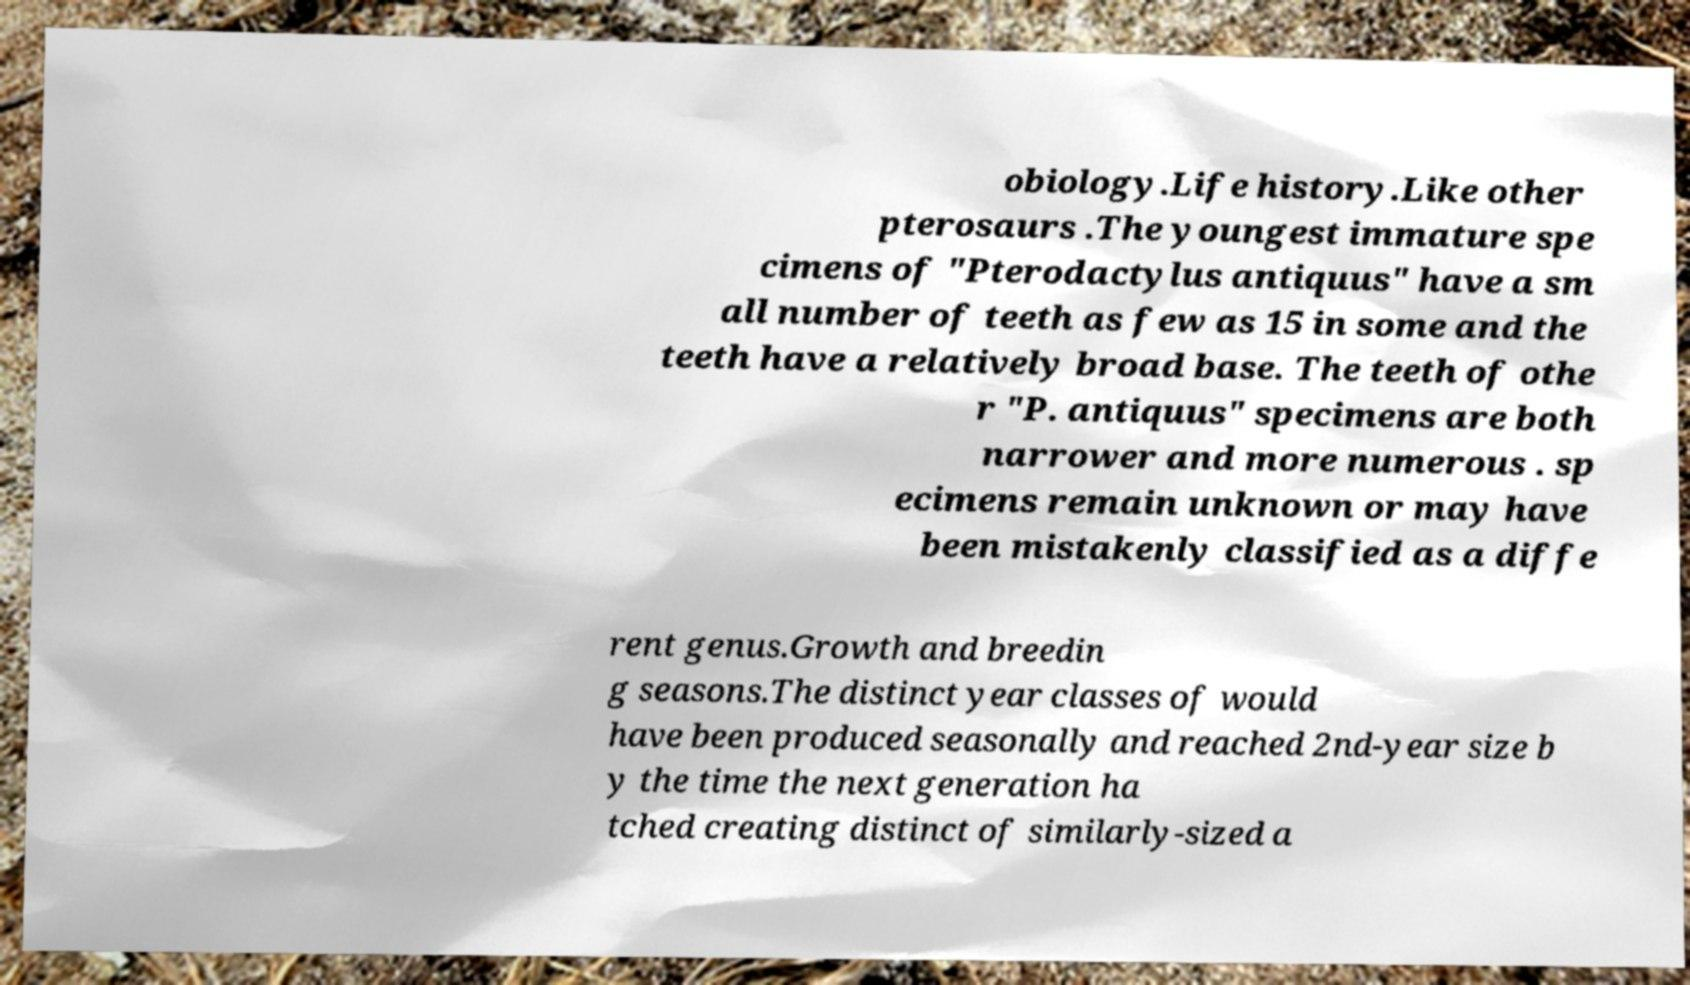Please identify and transcribe the text found in this image. obiology.Life history.Like other pterosaurs .The youngest immature spe cimens of "Pterodactylus antiquus" have a sm all number of teeth as few as 15 in some and the teeth have a relatively broad base. The teeth of othe r "P. antiquus" specimens are both narrower and more numerous . sp ecimens remain unknown or may have been mistakenly classified as a diffe rent genus.Growth and breedin g seasons.The distinct year classes of would have been produced seasonally and reached 2nd-year size b y the time the next generation ha tched creating distinct of similarly-sized a 